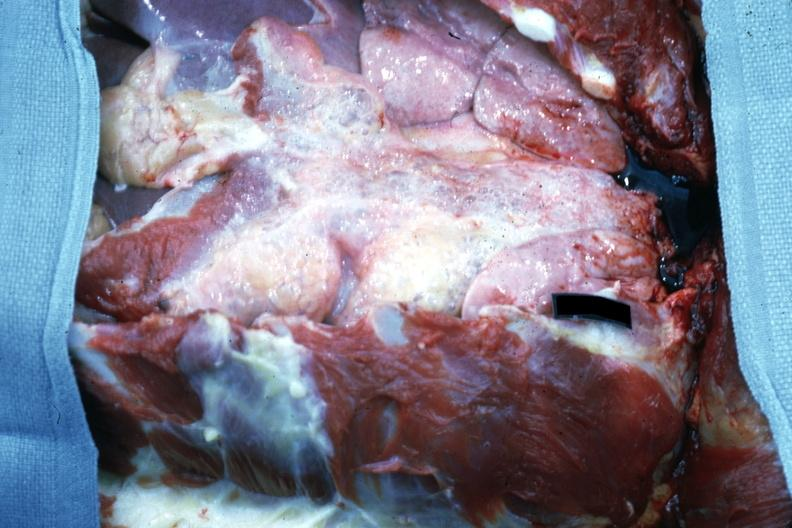what is opened chest with breast plate removed?
Answer the question using a single word or phrase. Easily seen air bubbles 